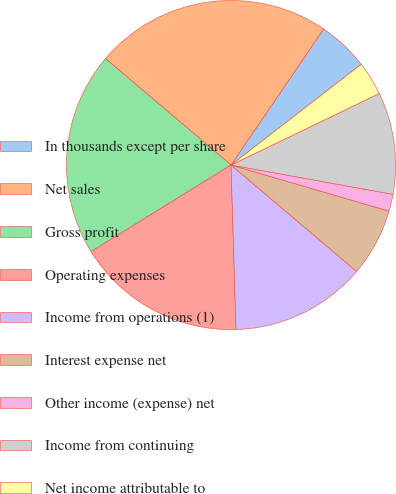<chart> <loc_0><loc_0><loc_500><loc_500><pie_chart><fcel>In thousands except per share<fcel>Net sales<fcel>Gross profit<fcel>Operating expenses<fcel>Income from operations (1)<fcel>Interest expense net<fcel>Other income (expense) net<fcel>Income from continuing<fcel>Net income attributable to<nl><fcel>5.0%<fcel>23.33%<fcel>20.0%<fcel>16.67%<fcel>13.33%<fcel>6.67%<fcel>1.67%<fcel>10.0%<fcel>3.33%<nl></chart> 